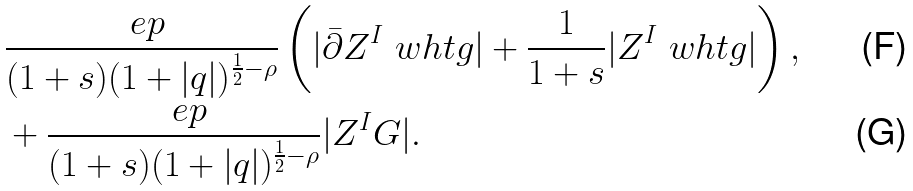Convert formula to latex. <formula><loc_0><loc_0><loc_500><loc_500>& \frac { \ e p } { ( 1 + s ) ( 1 + | q | ) ^ { \frac { 1 } { 2 } - \rho } } \left ( | \bar { \partial } Z ^ { I } \ w h t g | + \frac { 1 } { 1 + s } | Z ^ { I } \ w h t g | \right ) , \\ & + \frac { \ e p } { ( 1 + s ) ( 1 + | q | ) ^ { \frac { 1 } { 2 } - \rho } } | Z ^ { I } G | .</formula> 